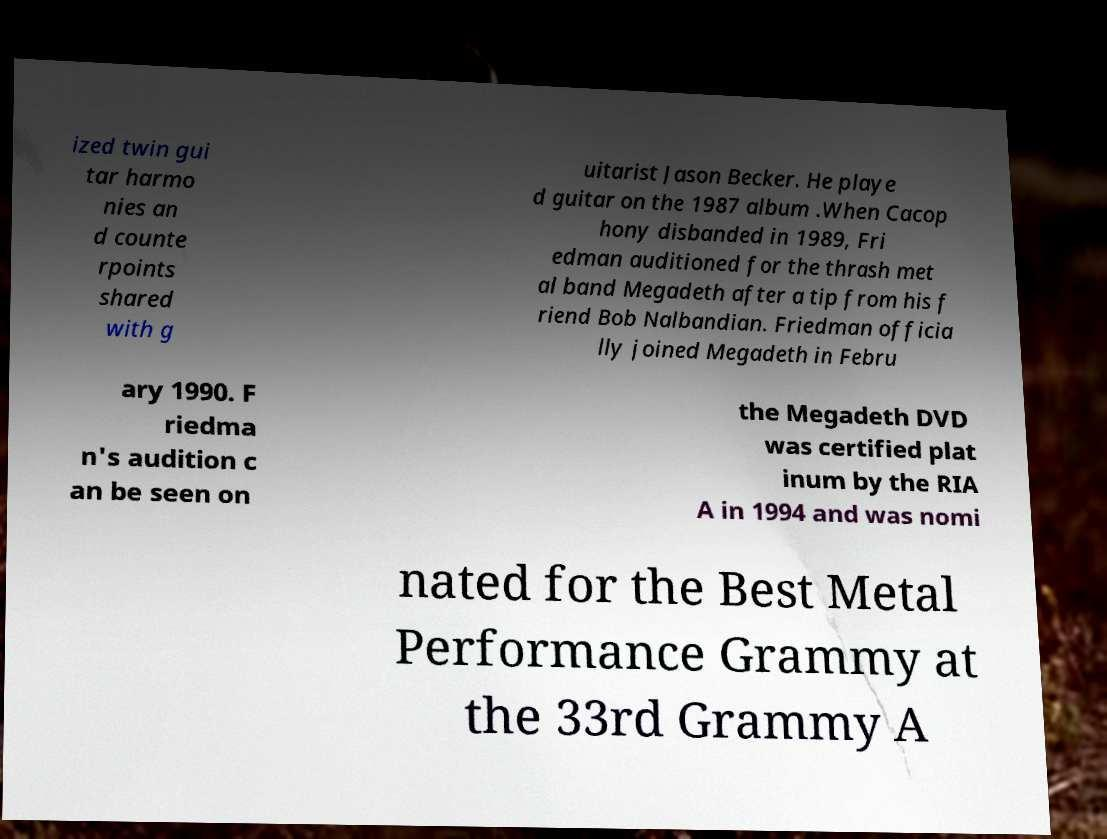Can you read and provide the text displayed in the image?This photo seems to have some interesting text. Can you extract and type it out for me? ized twin gui tar harmo nies an d counte rpoints shared with g uitarist Jason Becker. He playe d guitar on the 1987 album .When Cacop hony disbanded in 1989, Fri edman auditioned for the thrash met al band Megadeth after a tip from his f riend Bob Nalbandian. Friedman officia lly joined Megadeth in Febru ary 1990. F riedma n's audition c an be seen on the Megadeth DVD was certified plat inum by the RIA A in 1994 and was nomi nated for the Best Metal Performance Grammy at the 33rd Grammy A 